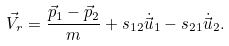Convert formula to latex. <formula><loc_0><loc_0><loc_500><loc_500>\vec { V } _ { r } & = \frac { \vec { p } _ { 1 } - \vec { p } _ { 2 } } { m } + s _ { 1 2 } \dot { \vec { u } } _ { 1 } - s _ { 2 1 } \dot { \vec { u } } _ { 2 } .</formula> 